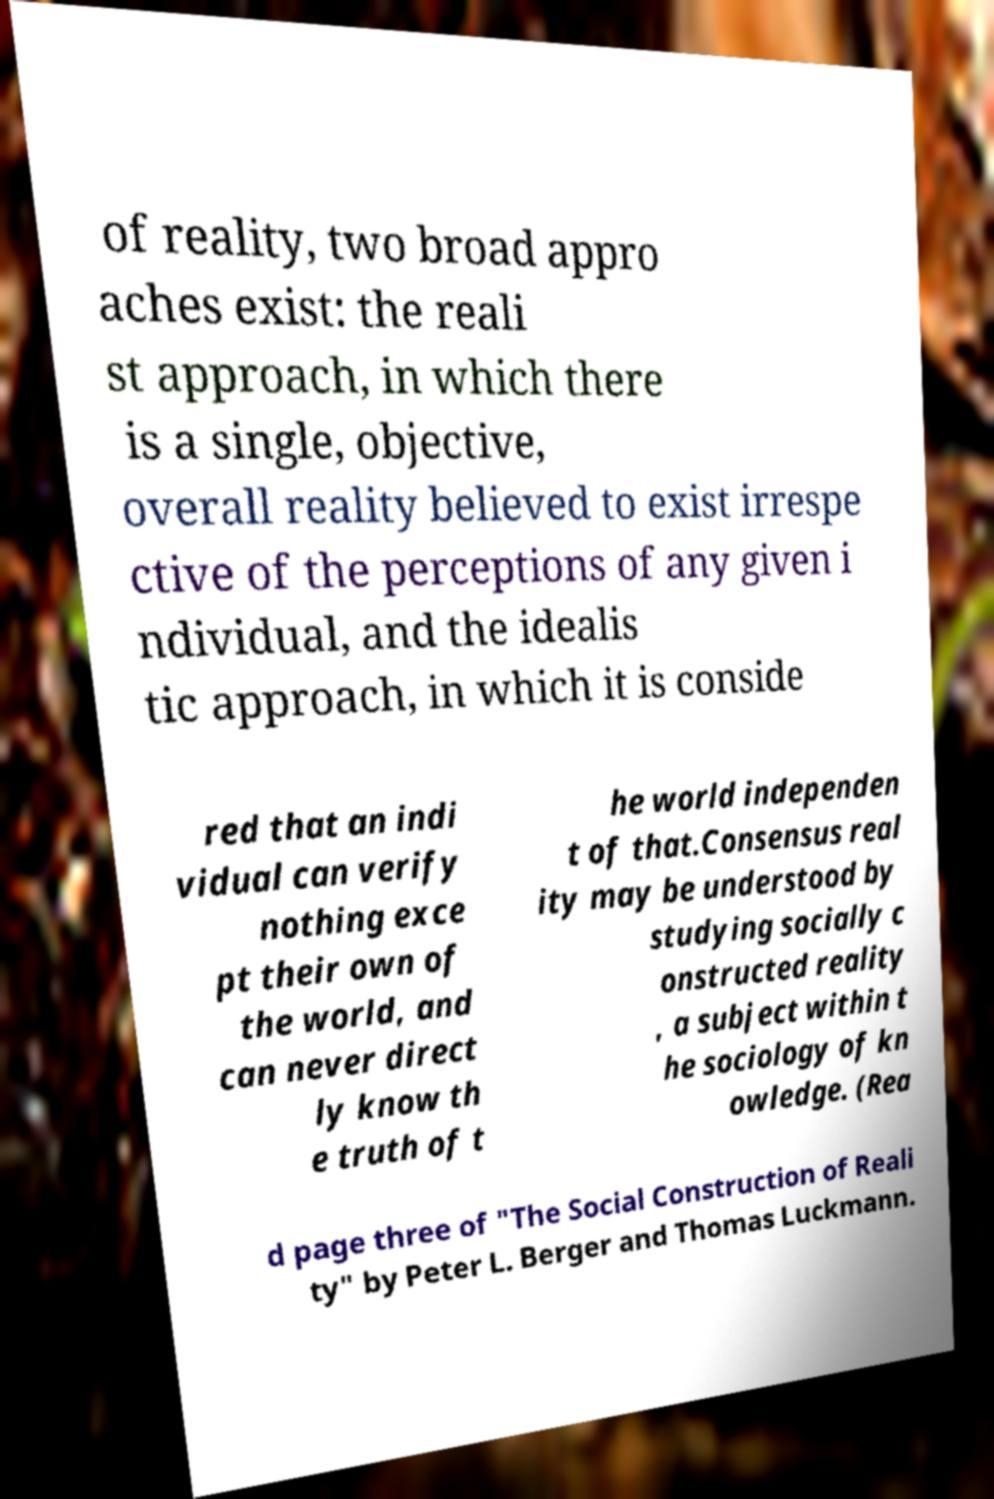Please read and relay the text visible in this image. What does it say? of reality, two broad appro aches exist: the reali st approach, in which there is a single, objective, overall reality believed to exist irrespe ctive of the perceptions of any given i ndividual, and the idealis tic approach, in which it is conside red that an indi vidual can verify nothing exce pt their own of the world, and can never direct ly know th e truth of t he world independen t of that.Consensus real ity may be understood by studying socially c onstructed reality , a subject within t he sociology of kn owledge. (Rea d page three of "The Social Construction of Reali ty" by Peter L. Berger and Thomas Luckmann. 